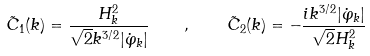<formula> <loc_0><loc_0><loc_500><loc_500>\tilde { C } _ { 1 } ( { k } ) = \frac { H _ { k } ^ { 2 } } { \sqrt { 2 } k ^ { 3 / 2 } | \dot { \varphi } _ { k } | } \quad , \quad \tilde { C } _ { 2 } ( { k } ) = - \frac { i k ^ { 3 / 2 } | \dot { \varphi } _ { k } | } { \sqrt { 2 } H _ { k } ^ { 2 } }</formula> 